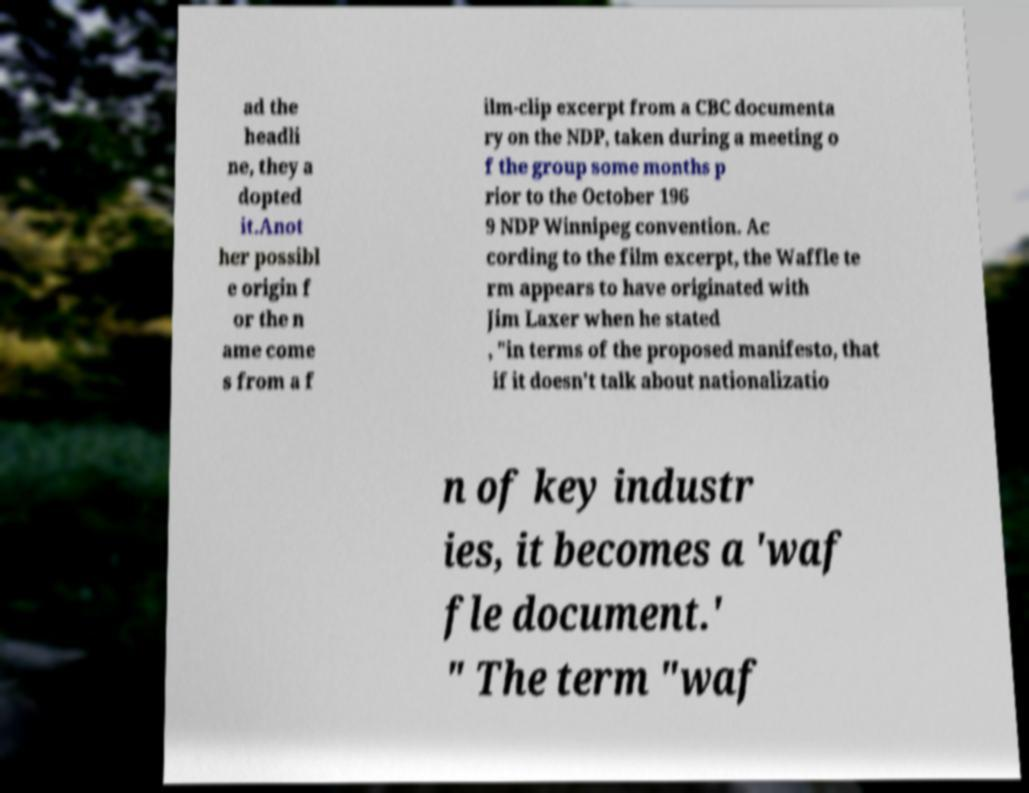I need the written content from this picture converted into text. Can you do that? ad the headli ne, they a dopted it.Anot her possibl e origin f or the n ame come s from a f ilm-clip excerpt from a CBC documenta ry on the NDP, taken during a meeting o f the group some months p rior to the October 196 9 NDP Winnipeg convention. Ac cording to the film excerpt, the Waffle te rm appears to have originated with Jim Laxer when he stated , "in terms of the proposed manifesto, that if it doesn't talk about nationalizatio n of key industr ies, it becomes a 'waf fle document.' " The term "waf 